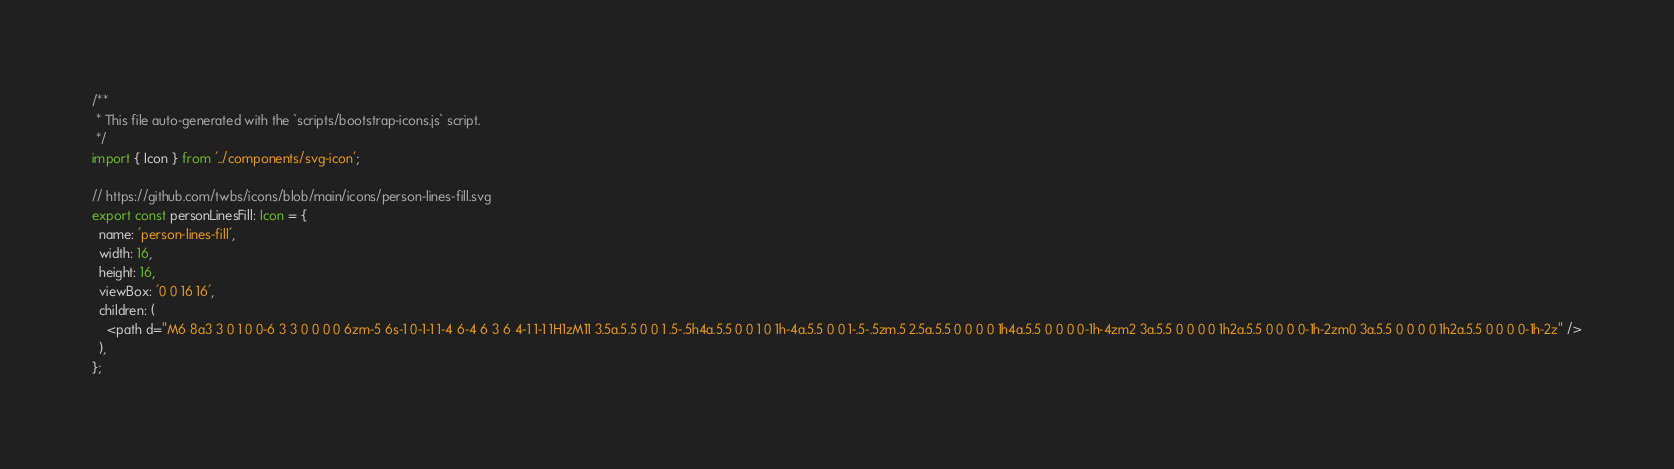Convert code to text. <code><loc_0><loc_0><loc_500><loc_500><_TypeScript_>/**
 * This file auto-generated with the `scripts/bootstrap-icons.js` script.
 */
import { Icon } from '../components/svg-icon';

// https://github.com/twbs/icons/blob/main/icons/person-lines-fill.svg
export const personLinesFill: Icon = {
  name: 'person-lines-fill',
  width: 16,
  height: 16,
  viewBox: '0 0 16 16',
  children: (
    <path d="M6 8a3 3 0 1 0 0-6 3 3 0 0 0 0 6zm-5 6s-1 0-1-1 1-4 6-4 6 3 6 4-1 1-1 1H1zM11 3.5a.5.5 0 0 1 .5-.5h4a.5.5 0 0 1 0 1h-4a.5.5 0 0 1-.5-.5zm.5 2.5a.5.5 0 0 0 0 1h4a.5.5 0 0 0 0-1h-4zm2 3a.5.5 0 0 0 0 1h2a.5.5 0 0 0 0-1h-2zm0 3a.5.5 0 0 0 0 1h2a.5.5 0 0 0 0-1h-2z" />
  ),
};
</code> 